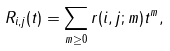<formula> <loc_0><loc_0><loc_500><loc_500>R _ { i , j } ( t ) = \sum _ { m \geq 0 } r ( i , j ; m ) t ^ { m } ,</formula> 